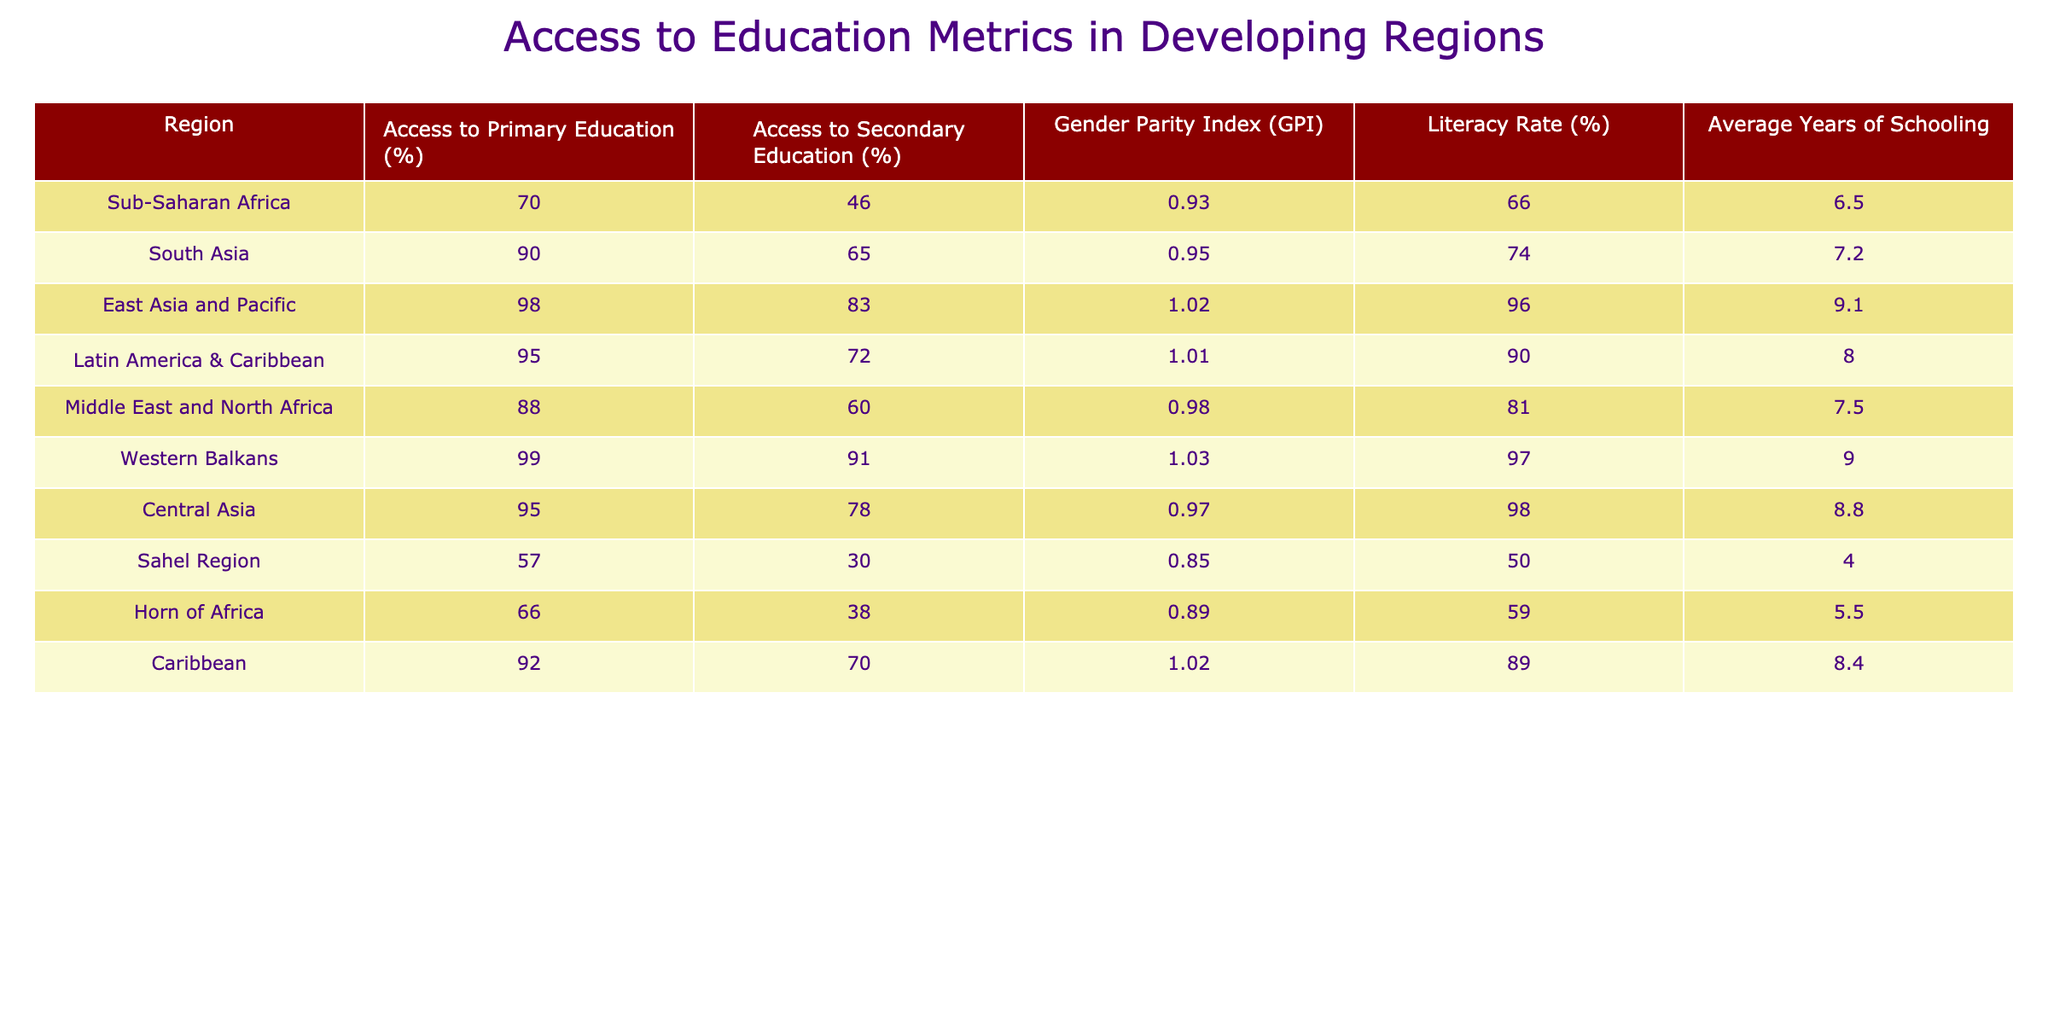What region has the highest access to primary education? Referring to the table, the highest access to primary education is 99%, which corresponds to the Western Balkans.
Answer: Western Balkans What is the literacy rate in the Sahel Region? Looking at the table, the Sahel Region has a literacy rate of 50%.
Answer: 50% What is the Gender Parity Index (GPI) for East Asia and the Pacific? The table shows that the GPI for East Asia and Pacific is 1.02.
Answer: 1.02 Calculate the average access to secondary education across all regions listed. To find the average access to secondary education, first sum all the secondary education percentages: 46 + 65 + 83 + 72 + 60 + 91 + 78 + 30 + 38 + 70 =  563. Then, divide by the number of regions (10): 563 / 10 = 56.3.
Answer: 56.3 Is the average years of schooling in South Asia higher than in the Horn of Africa? South Asia has an average of 7.2 years of schooling, while the Horn of Africa has an average of 5.5 years. Since 7.2 is greater than 5.5, the answer is yes.
Answer: Yes What region has the lowest access to secondary education and what is that percentage? The lowest access to secondary education is found in the Sahel Region at 30%.
Answer: Sahel Region, 30% Which region has both a high access to primary education and a high literacy rate? By examining the table, both East Asia and Pacific (98% primary education and 96% literacy) and Latin America & Caribbean (95% primary education and 90% literacy) fit this description, but East Asia and Pacific has higher metrics overall.
Answer: East Asia and Pacific How many regions have access to primary education above 90%? The regions with access to primary education above 90% are South Asia, East Asia and Pacific, Latin America & Caribbean, and Western Balkans. Thus, there are 4 regions.
Answer: 4 Is there a correlation between the Gender Parity Index (GPI) and access to secondary education in the regions? Checking the GPI and access to secondary education, there are variations; however, regions with higher GPI values like the Western Balkans and East Asia also show higher access to secondary education. Thus, while not definitive, a tendency indicates a positive correlation.
Answer: Positive tendency 